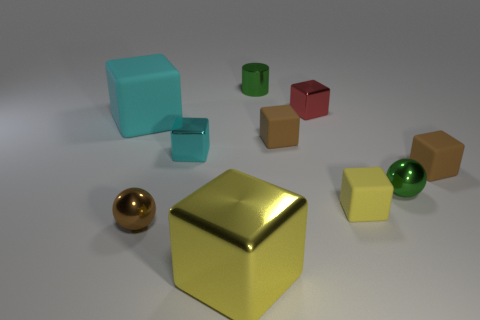Subtract all tiny rubber blocks. How many blocks are left? 4 Subtract all spheres. How many objects are left? 8 Subtract all gray balls. How many yellow cylinders are left? 0 Subtract all big yellow rubber objects. Subtract all small brown matte blocks. How many objects are left? 8 Add 5 small blocks. How many small blocks are left? 10 Add 9 large metallic blocks. How many large metallic blocks exist? 10 Subtract all brown balls. How many balls are left? 1 Subtract 1 brown spheres. How many objects are left? 9 Subtract 4 blocks. How many blocks are left? 3 Subtract all green spheres. Subtract all purple cylinders. How many spheres are left? 1 